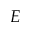Convert formula to latex. <formula><loc_0><loc_0><loc_500><loc_500>E</formula> 